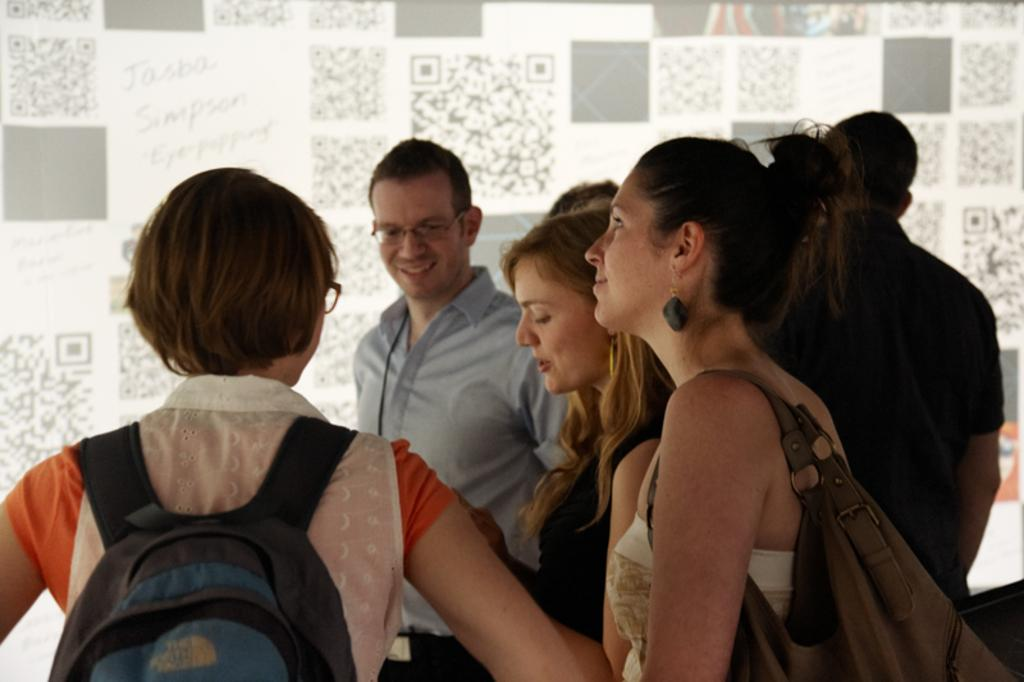What types of people are present in the image? There are men and women in the image. What are the men and women doing in the image? The men and women are standing in the image. What expressions do the men and women have in the image? The men and women are smiling in the image. What are the women wearing in the image? The women are wearing bags in the image. What type of work are the men and women doing in the image? The image does not provide any information about the men and women working or performing any specific tasks. How much milk can be seen in the image? There is no milk present in the image. What color are the eyes of the men and women in the image? The image does not provide any information about the color of the men and women's eyes. 